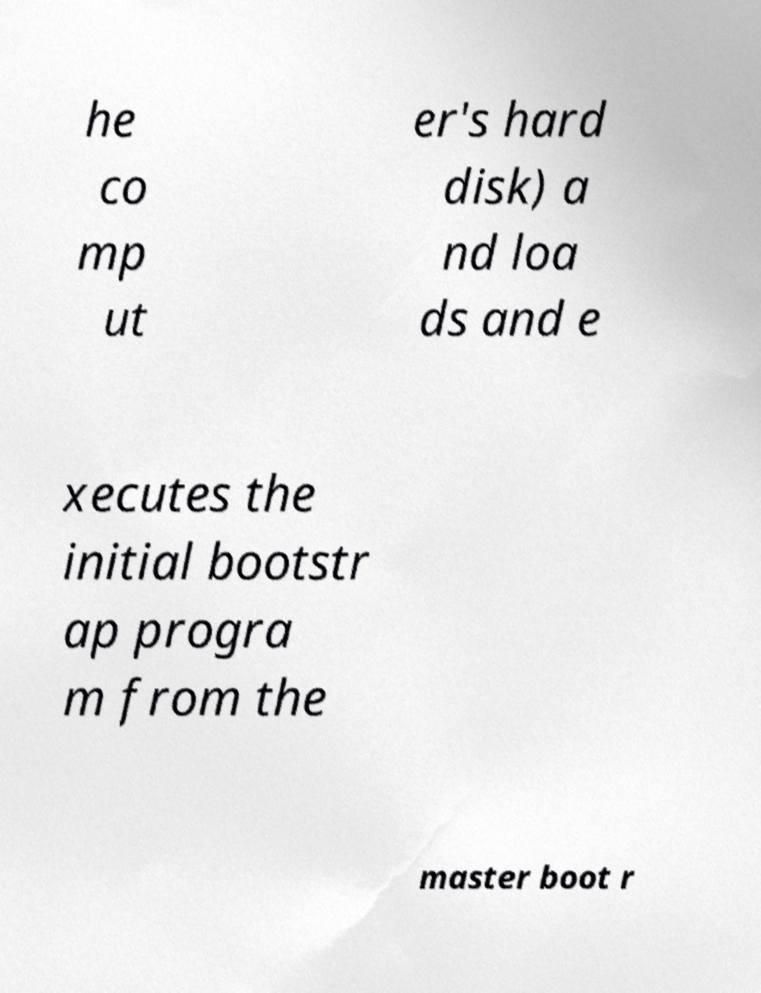For documentation purposes, I need the text within this image transcribed. Could you provide that? he co mp ut er's hard disk) a nd loa ds and e xecutes the initial bootstr ap progra m from the master boot r 